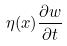<formula> <loc_0><loc_0><loc_500><loc_500>\eta ( x ) \frac { \partial w } { \partial t }</formula> 